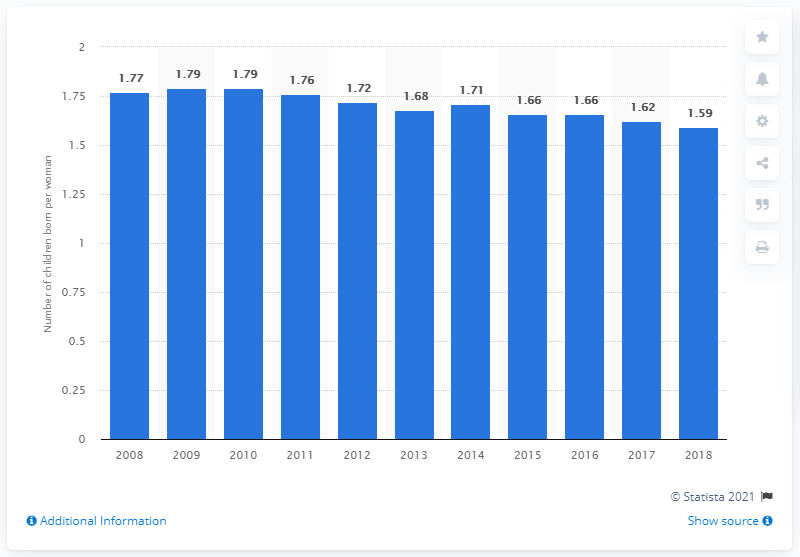Give some essential details in this illustration. In 2018, the fertility rate in the Netherlands was 1.59. 